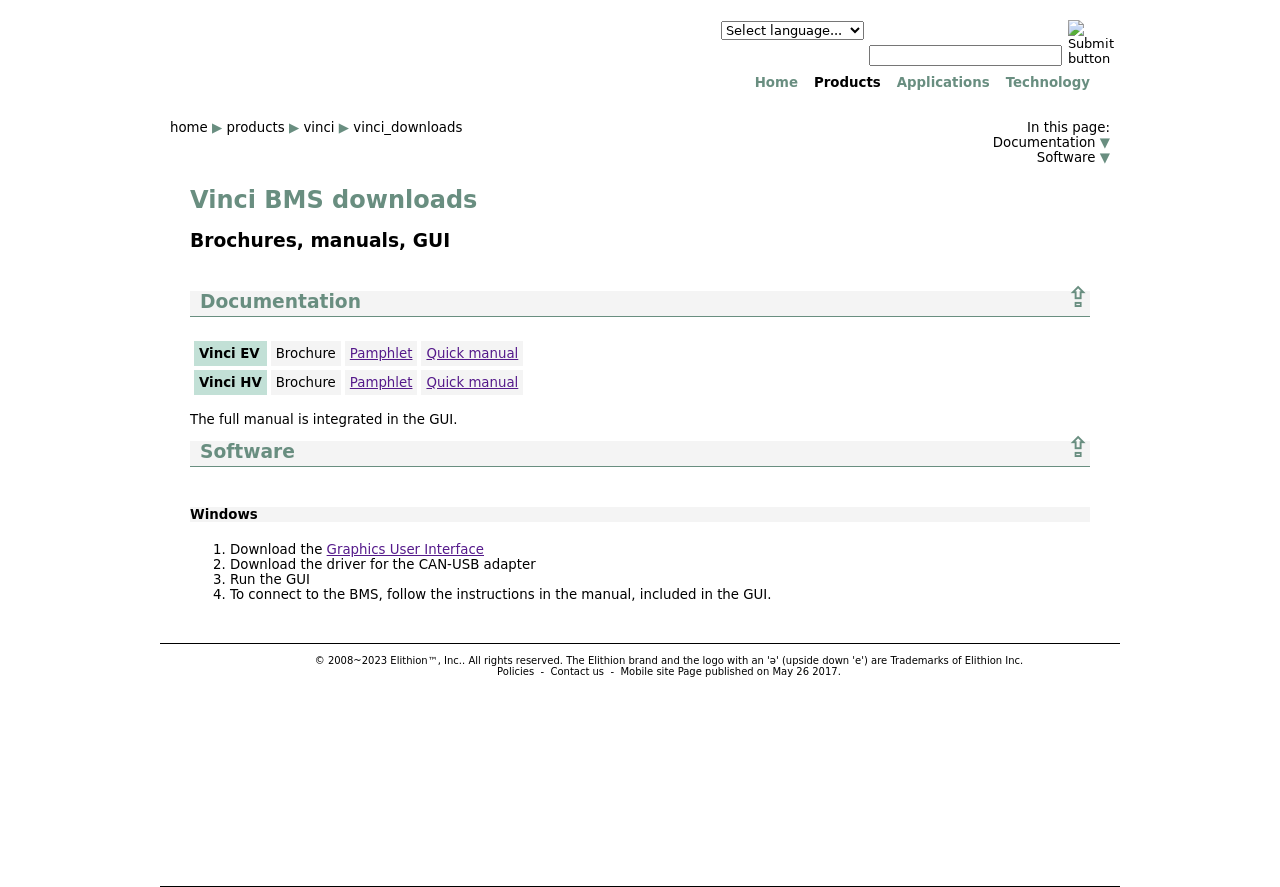Where can I find the documentation for Vinci HV products? The documentation for Vinci HV products can be found in the 'Documentation' section of the webpage shown in the image. You can click on the links labeled Brochure, Pamphlet, or Quick manual to access the respective documents.  What steps should I follow to install the software for Windows from this website? To install the software for Windows, you should follow these steps as per the 'Software' section on the website: First, download the Graphics User Interface and the driver for the CAN-USB adapter from the provided links. Then, run the GUI, and to connect to the BMS, follow the detailed instructions included in the manual which is integrated into the GUI. 